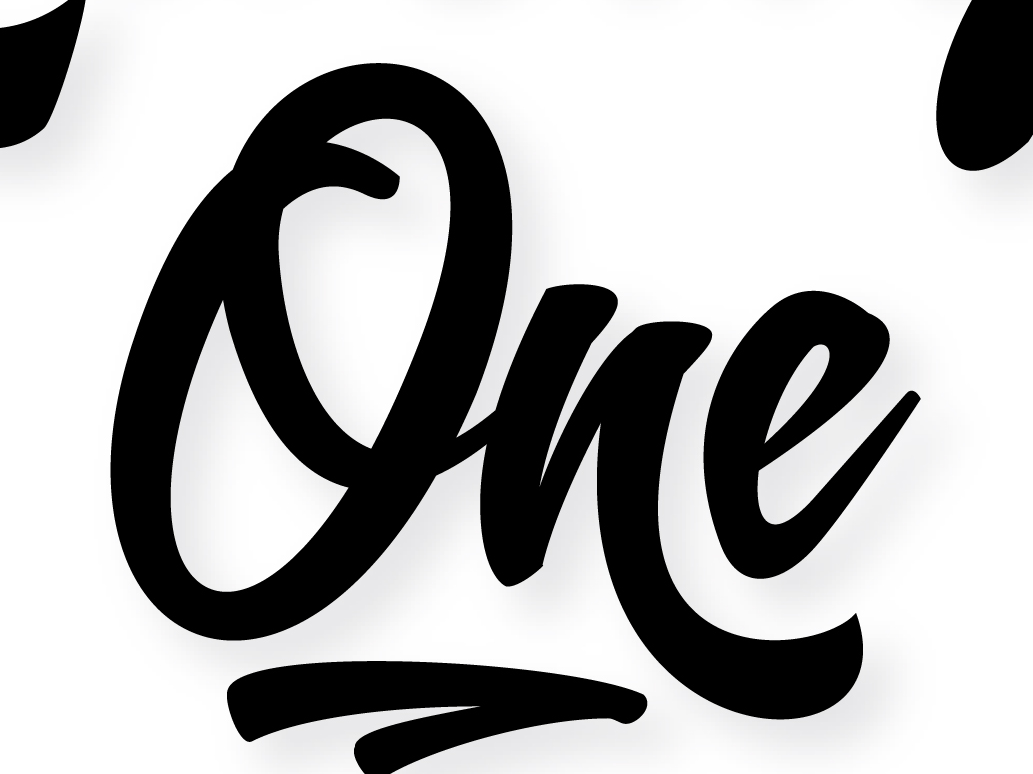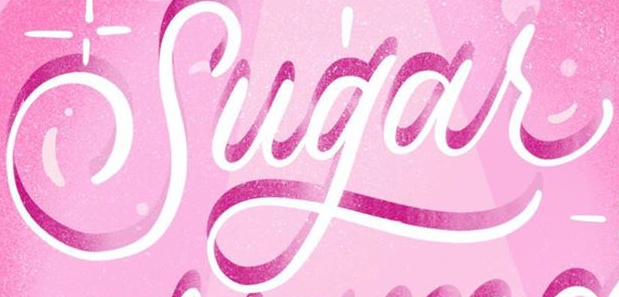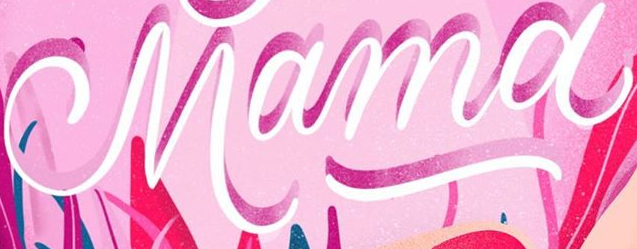Read the text from these images in sequence, separated by a semicolon. One; Sugar; Mama 